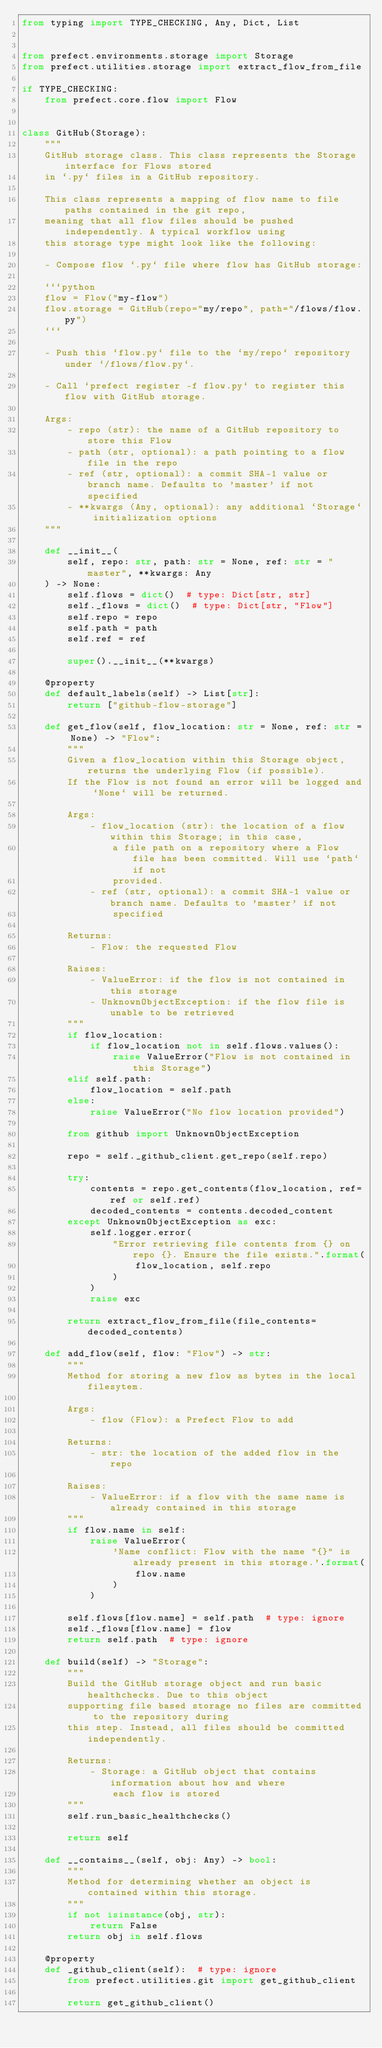<code> <loc_0><loc_0><loc_500><loc_500><_Python_>from typing import TYPE_CHECKING, Any, Dict, List


from prefect.environments.storage import Storage
from prefect.utilities.storage import extract_flow_from_file

if TYPE_CHECKING:
    from prefect.core.flow import Flow


class GitHub(Storage):
    """
    GitHub storage class. This class represents the Storage interface for Flows stored
    in `.py` files in a GitHub repository.

    This class represents a mapping of flow name to file paths contained in the git repo,
    meaning that all flow files should be pushed independently. A typical workflow using
    this storage type might look like the following:

    - Compose flow `.py` file where flow has GitHub storage:

    ```python
    flow = Flow("my-flow")
    flow.storage = GitHub(repo="my/repo", path="/flows/flow.py")
    ```

    - Push this `flow.py` file to the `my/repo` repository under `/flows/flow.py`.

    - Call `prefect register -f flow.py` to register this flow with GitHub storage.

    Args:
        - repo (str): the name of a GitHub repository to store this Flow
        - path (str, optional): a path pointing to a flow file in the repo
        - ref (str, optional): a commit SHA-1 value or branch name. Defaults to 'master' if not specified
        - **kwargs (Any, optional): any additional `Storage` initialization options
    """

    def __init__(
        self, repo: str, path: str = None, ref: str = "master", **kwargs: Any
    ) -> None:
        self.flows = dict()  # type: Dict[str, str]
        self._flows = dict()  # type: Dict[str, "Flow"]
        self.repo = repo
        self.path = path
        self.ref = ref

        super().__init__(**kwargs)

    @property
    def default_labels(self) -> List[str]:
        return ["github-flow-storage"]

    def get_flow(self, flow_location: str = None, ref: str = None) -> "Flow":
        """
        Given a flow_location within this Storage object, returns the underlying Flow (if possible).
        If the Flow is not found an error will be logged and `None` will be returned.

        Args:
            - flow_location (str): the location of a flow within this Storage; in this case,
                a file path on a repository where a Flow file has been committed. Will use `path` if not
                provided.
            - ref (str, optional): a commit SHA-1 value or branch name. Defaults to 'master' if not
                specified

        Returns:
            - Flow: the requested Flow

        Raises:
            - ValueError: if the flow is not contained in this storage
            - UnknownObjectException: if the flow file is unable to be retrieved
        """
        if flow_location:
            if flow_location not in self.flows.values():
                raise ValueError("Flow is not contained in this Storage")
        elif self.path:
            flow_location = self.path
        else:
            raise ValueError("No flow location provided")

        from github import UnknownObjectException

        repo = self._github_client.get_repo(self.repo)

        try:
            contents = repo.get_contents(flow_location, ref=ref or self.ref)
            decoded_contents = contents.decoded_content
        except UnknownObjectException as exc:
            self.logger.error(
                "Error retrieving file contents from {} on repo {}. Ensure the file exists.".format(
                    flow_location, self.repo
                )
            )
            raise exc

        return extract_flow_from_file(file_contents=decoded_contents)

    def add_flow(self, flow: "Flow") -> str:
        """
        Method for storing a new flow as bytes in the local filesytem.

        Args:
            - flow (Flow): a Prefect Flow to add

        Returns:
            - str: the location of the added flow in the repo

        Raises:
            - ValueError: if a flow with the same name is already contained in this storage
        """
        if flow.name in self:
            raise ValueError(
                'Name conflict: Flow with the name "{}" is already present in this storage.'.format(
                    flow.name
                )
            )

        self.flows[flow.name] = self.path  # type: ignore
        self._flows[flow.name] = flow
        return self.path  # type: ignore

    def build(self) -> "Storage":
        """
        Build the GitHub storage object and run basic healthchecks. Due to this object
        supporting file based storage no files are committed to the repository during
        this step. Instead, all files should be committed independently.

        Returns:
            - Storage: a GitHub object that contains information about how and where
                each flow is stored
        """
        self.run_basic_healthchecks()

        return self

    def __contains__(self, obj: Any) -> bool:
        """
        Method for determining whether an object is contained within this storage.
        """
        if not isinstance(obj, str):
            return False
        return obj in self.flows

    @property
    def _github_client(self):  # type: ignore
        from prefect.utilities.git import get_github_client

        return get_github_client()
</code> 